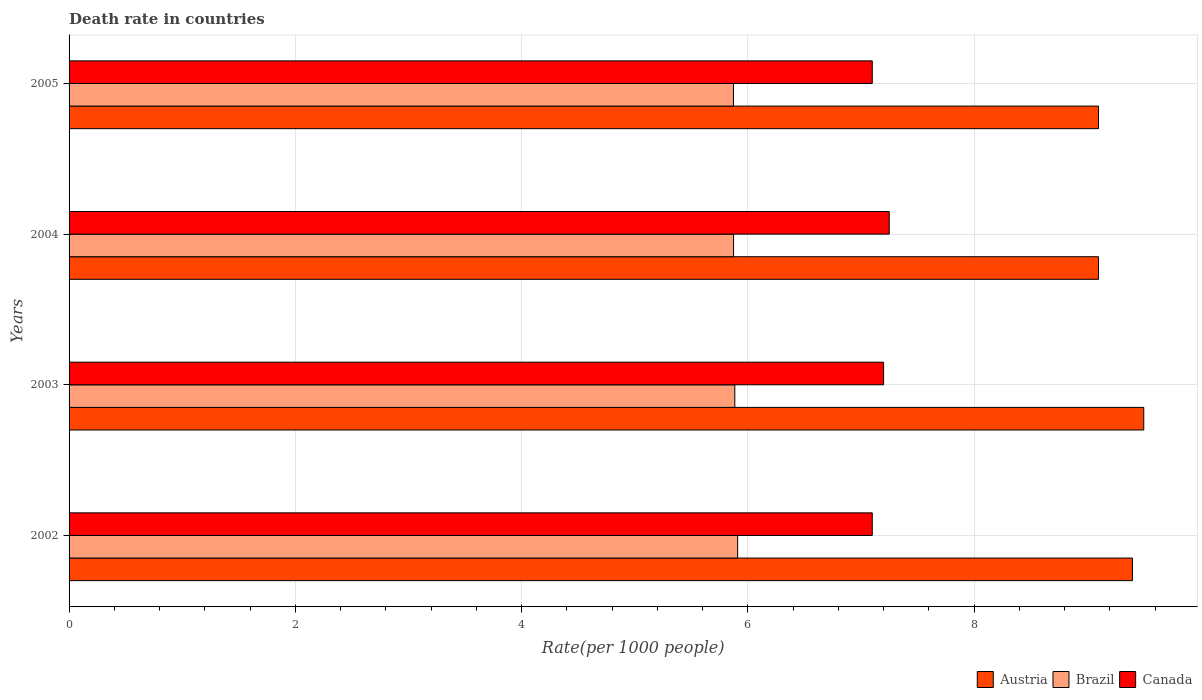How many different coloured bars are there?
Ensure brevity in your answer.  3. How many groups of bars are there?
Offer a very short reply. 4. How many bars are there on the 1st tick from the top?
Provide a short and direct response. 3. What is the death rate in Canada in 2003?
Offer a very short reply. 7.2. Across all years, what is the maximum death rate in Canada?
Your response must be concise. 7.25. Across all years, what is the minimum death rate in Brazil?
Your answer should be very brief. 5.87. In which year was the death rate in Brazil maximum?
Make the answer very short. 2002. What is the total death rate in Canada in the graph?
Make the answer very short. 28.65. What is the difference between the death rate in Austria in 2002 and that in 2004?
Keep it short and to the point. 0.3. What is the difference between the death rate in Austria in 2004 and the death rate in Brazil in 2003?
Make the answer very short. 3.21. What is the average death rate in Austria per year?
Give a very brief answer. 9.28. In the year 2003, what is the difference between the death rate in Austria and death rate in Canada?
Your answer should be compact. 2.3. In how many years, is the death rate in Brazil greater than 7.2 ?
Make the answer very short. 0. What is the ratio of the death rate in Canada in 2003 to that in 2004?
Offer a terse response. 0.99. What is the difference between the highest and the second highest death rate in Canada?
Provide a succinct answer. 0.05. What is the difference between the highest and the lowest death rate in Brazil?
Give a very brief answer. 0.04. Is the sum of the death rate in Austria in 2004 and 2005 greater than the maximum death rate in Brazil across all years?
Make the answer very short. Yes. Is it the case that in every year, the sum of the death rate in Brazil and death rate in Canada is greater than the death rate in Austria?
Provide a short and direct response. Yes. What is the difference between two consecutive major ticks on the X-axis?
Offer a very short reply. 2. Are the values on the major ticks of X-axis written in scientific E-notation?
Your answer should be very brief. No. Does the graph contain grids?
Provide a short and direct response. Yes. How many legend labels are there?
Offer a very short reply. 3. How are the legend labels stacked?
Ensure brevity in your answer.  Horizontal. What is the title of the graph?
Offer a very short reply. Death rate in countries. What is the label or title of the X-axis?
Ensure brevity in your answer.  Rate(per 1000 people). What is the Rate(per 1000 people) of Austria in 2002?
Offer a very short reply. 9.4. What is the Rate(per 1000 people) in Brazil in 2002?
Offer a very short reply. 5.91. What is the Rate(per 1000 people) of Canada in 2002?
Ensure brevity in your answer.  7.1. What is the Rate(per 1000 people) of Brazil in 2003?
Offer a terse response. 5.88. What is the Rate(per 1000 people) in Brazil in 2004?
Your answer should be very brief. 5.87. What is the Rate(per 1000 people) in Canada in 2004?
Your response must be concise. 7.25. What is the Rate(per 1000 people) of Austria in 2005?
Ensure brevity in your answer.  9.1. What is the Rate(per 1000 people) of Brazil in 2005?
Your answer should be very brief. 5.87. Across all years, what is the maximum Rate(per 1000 people) of Brazil?
Ensure brevity in your answer.  5.91. Across all years, what is the maximum Rate(per 1000 people) of Canada?
Ensure brevity in your answer.  7.25. Across all years, what is the minimum Rate(per 1000 people) in Brazil?
Offer a very short reply. 5.87. Across all years, what is the minimum Rate(per 1000 people) of Canada?
Provide a short and direct response. 7.1. What is the total Rate(per 1000 people) in Austria in the graph?
Your answer should be compact. 37.1. What is the total Rate(per 1000 people) in Brazil in the graph?
Give a very brief answer. 23.54. What is the total Rate(per 1000 people) of Canada in the graph?
Keep it short and to the point. 28.65. What is the difference between the Rate(per 1000 people) in Austria in 2002 and that in 2003?
Offer a terse response. -0.1. What is the difference between the Rate(per 1000 people) of Brazil in 2002 and that in 2003?
Offer a very short reply. 0.03. What is the difference between the Rate(per 1000 people) of Austria in 2002 and that in 2004?
Provide a succinct answer. 0.3. What is the difference between the Rate(per 1000 people) in Brazil in 2002 and that in 2004?
Provide a succinct answer. 0.04. What is the difference between the Rate(per 1000 people) of Brazil in 2002 and that in 2005?
Your answer should be very brief. 0.04. What is the difference between the Rate(per 1000 people) of Brazil in 2003 and that in 2004?
Your response must be concise. 0.01. What is the difference between the Rate(per 1000 people) of Canada in 2003 and that in 2004?
Provide a succinct answer. -0.05. What is the difference between the Rate(per 1000 people) in Brazil in 2003 and that in 2005?
Keep it short and to the point. 0.01. What is the difference between the Rate(per 1000 people) of Canada in 2003 and that in 2005?
Make the answer very short. 0.1. What is the difference between the Rate(per 1000 people) of Brazil in 2004 and that in 2005?
Ensure brevity in your answer.  0. What is the difference between the Rate(per 1000 people) in Austria in 2002 and the Rate(per 1000 people) in Brazil in 2003?
Ensure brevity in your answer.  3.52. What is the difference between the Rate(per 1000 people) in Austria in 2002 and the Rate(per 1000 people) in Canada in 2003?
Make the answer very short. 2.2. What is the difference between the Rate(per 1000 people) in Brazil in 2002 and the Rate(per 1000 people) in Canada in 2003?
Provide a succinct answer. -1.29. What is the difference between the Rate(per 1000 people) in Austria in 2002 and the Rate(per 1000 people) in Brazil in 2004?
Provide a short and direct response. 3.53. What is the difference between the Rate(per 1000 people) of Austria in 2002 and the Rate(per 1000 people) of Canada in 2004?
Provide a short and direct response. 2.15. What is the difference between the Rate(per 1000 people) of Brazil in 2002 and the Rate(per 1000 people) of Canada in 2004?
Offer a very short reply. -1.34. What is the difference between the Rate(per 1000 people) of Austria in 2002 and the Rate(per 1000 people) of Brazil in 2005?
Your answer should be compact. 3.53. What is the difference between the Rate(per 1000 people) of Brazil in 2002 and the Rate(per 1000 people) of Canada in 2005?
Offer a very short reply. -1.19. What is the difference between the Rate(per 1000 people) in Austria in 2003 and the Rate(per 1000 people) in Brazil in 2004?
Offer a very short reply. 3.63. What is the difference between the Rate(per 1000 people) in Austria in 2003 and the Rate(per 1000 people) in Canada in 2004?
Offer a very short reply. 2.25. What is the difference between the Rate(per 1000 people) of Brazil in 2003 and the Rate(per 1000 people) of Canada in 2004?
Your response must be concise. -1.36. What is the difference between the Rate(per 1000 people) of Austria in 2003 and the Rate(per 1000 people) of Brazil in 2005?
Keep it short and to the point. 3.63. What is the difference between the Rate(per 1000 people) of Brazil in 2003 and the Rate(per 1000 people) of Canada in 2005?
Ensure brevity in your answer.  -1.22. What is the difference between the Rate(per 1000 people) in Austria in 2004 and the Rate(per 1000 people) in Brazil in 2005?
Provide a succinct answer. 3.23. What is the difference between the Rate(per 1000 people) of Brazil in 2004 and the Rate(per 1000 people) of Canada in 2005?
Make the answer very short. -1.23. What is the average Rate(per 1000 people) of Austria per year?
Ensure brevity in your answer.  9.28. What is the average Rate(per 1000 people) in Brazil per year?
Offer a very short reply. 5.89. What is the average Rate(per 1000 people) in Canada per year?
Keep it short and to the point. 7.16. In the year 2002, what is the difference between the Rate(per 1000 people) in Austria and Rate(per 1000 people) in Brazil?
Offer a terse response. 3.49. In the year 2002, what is the difference between the Rate(per 1000 people) in Austria and Rate(per 1000 people) in Canada?
Provide a succinct answer. 2.3. In the year 2002, what is the difference between the Rate(per 1000 people) in Brazil and Rate(per 1000 people) in Canada?
Offer a terse response. -1.19. In the year 2003, what is the difference between the Rate(per 1000 people) in Austria and Rate(per 1000 people) in Brazil?
Make the answer very short. 3.62. In the year 2003, what is the difference between the Rate(per 1000 people) of Austria and Rate(per 1000 people) of Canada?
Your response must be concise. 2.3. In the year 2003, what is the difference between the Rate(per 1000 people) in Brazil and Rate(per 1000 people) in Canada?
Offer a terse response. -1.31. In the year 2004, what is the difference between the Rate(per 1000 people) in Austria and Rate(per 1000 people) in Brazil?
Your answer should be very brief. 3.23. In the year 2004, what is the difference between the Rate(per 1000 people) of Austria and Rate(per 1000 people) of Canada?
Provide a short and direct response. 1.85. In the year 2004, what is the difference between the Rate(per 1000 people) of Brazil and Rate(per 1000 people) of Canada?
Provide a succinct answer. -1.38. In the year 2005, what is the difference between the Rate(per 1000 people) of Austria and Rate(per 1000 people) of Brazil?
Provide a succinct answer. 3.23. In the year 2005, what is the difference between the Rate(per 1000 people) in Austria and Rate(per 1000 people) in Canada?
Make the answer very short. 2. In the year 2005, what is the difference between the Rate(per 1000 people) of Brazil and Rate(per 1000 people) of Canada?
Offer a very short reply. -1.23. What is the ratio of the Rate(per 1000 people) of Brazil in 2002 to that in 2003?
Your response must be concise. 1. What is the ratio of the Rate(per 1000 people) in Canada in 2002 to that in 2003?
Your answer should be very brief. 0.99. What is the ratio of the Rate(per 1000 people) in Austria in 2002 to that in 2004?
Your answer should be compact. 1.03. What is the ratio of the Rate(per 1000 people) in Canada in 2002 to that in 2004?
Offer a very short reply. 0.98. What is the ratio of the Rate(per 1000 people) in Austria in 2002 to that in 2005?
Make the answer very short. 1.03. What is the ratio of the Rate(per 1000 people) of Brazil in 2002 to that in 2005?
Give a very brief answer. 1.01. What is the ratio of the Rate(per 1000 people) of Canada in 2002 to that in 2005?
Your response must be concise. 1. What is the ratio of the Rate(per 1000 people) in Austria in 2003 to that in 2004?
Give a very brief answer. 1.04. What is the ratio of the Rate(per 1000 people) of Austria in 2003 to that in 2005?
Provide a short and direct response. 1.04. What is the ratio of the Rate(per 1000 people) of Brazil in 2003 to that in 2005?
Offer a terse response. 1. What is the ratio of the Rate(per 1000 people) of Canada in 2003 to that in 2005?
Your response must be concise. 1.01. What is the ratio of the Rate(per 1000 people) in Brazil in 2004 to that in 2005?
Your answer should be compact. 1. What is the ratio of the Rate(per 1000 people) of Canada in 2004 to that in 2005?
Offer a terse response. 1.02. What is the difference between the highest and the second highest Rate(per 1000 people) in Austria?
Keep it short and to the point. 0.1. What is the difference between the highest and the second highest Rate(per 1000 people) in Brazil?
Ensure brevity in your answer.  0.03. What is the difference between the highest and the second highest Rate(per 1000 people) in Canada?
Make the answer very short. 0.05. What is the difference between the highest and the lowest Rate(per 1000 people) in Brazil?
Keep it short and to the point. 0.04. 